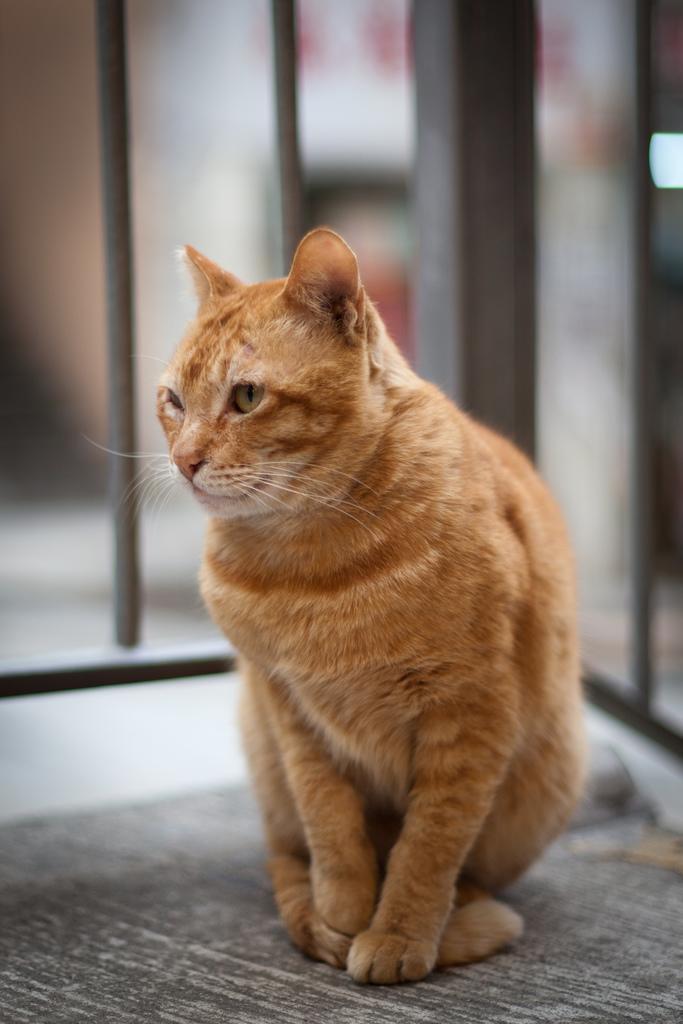In one or two sentences, can you explain what this image depicts? In this image I can see a cat which is cream and brown in color is on the black and white colored surface. In the background I can see few blurry objects. 